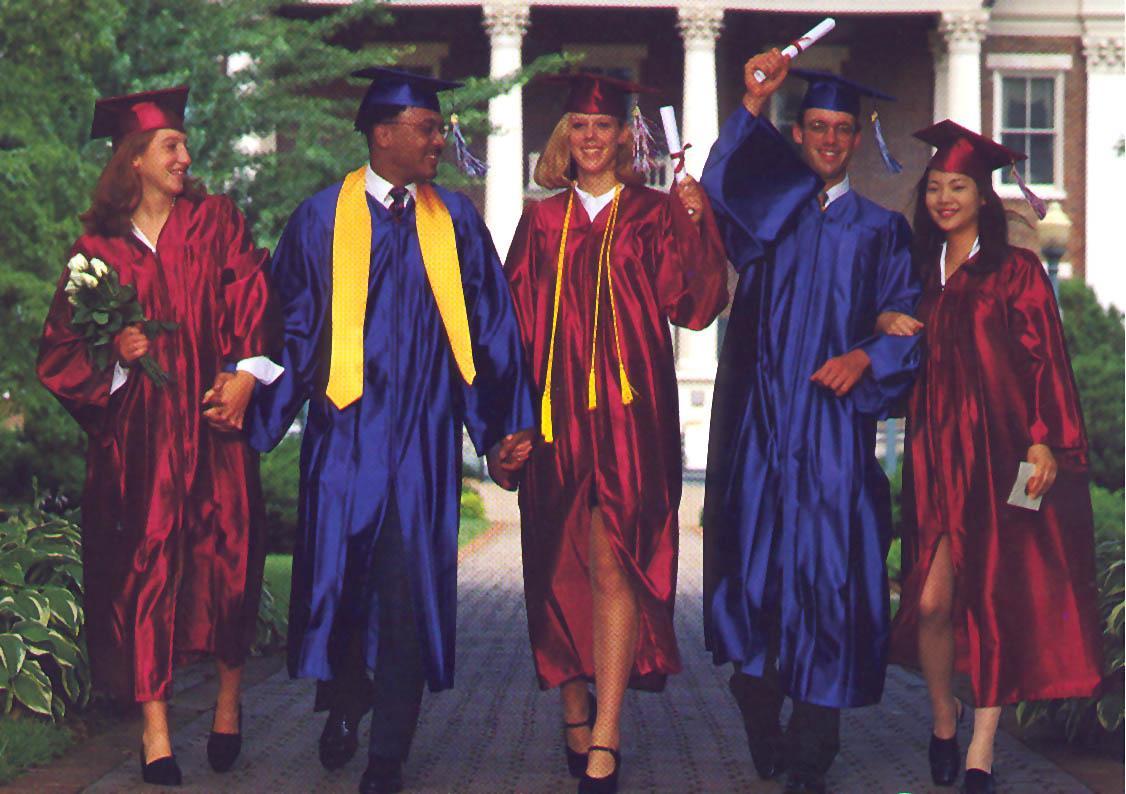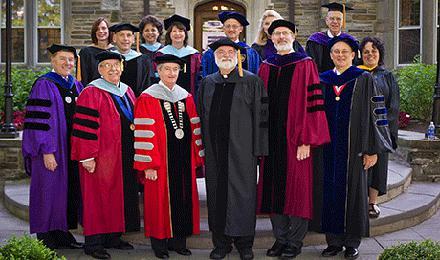The first image is the image on the left, the second image is the image on the right. Evaluate the accuracy of this statement regarding the images: "Graduates are standing on the sidewalk in the image on the left.". Is it true? Answer yes or no. Yes. The first image is the image on the left, the second image is the image on the right. Given the left and right images, does the statement "Right image shows at least one person in a dark red graduation gown with black stripes on the sleeves." hold true? Answer yes or no. Yes. 